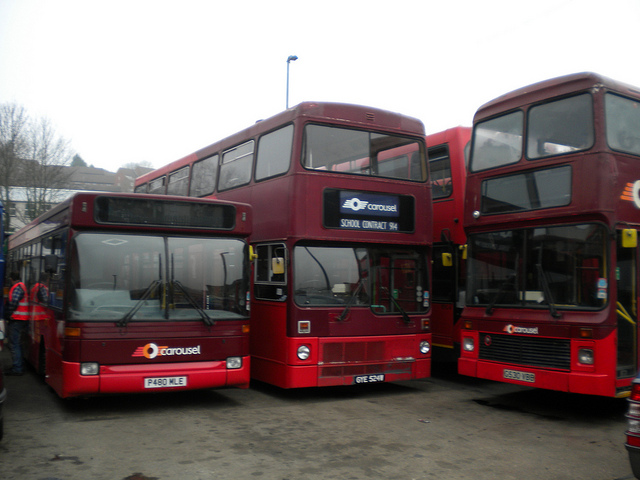Identify and read out the text in this image. corousel 